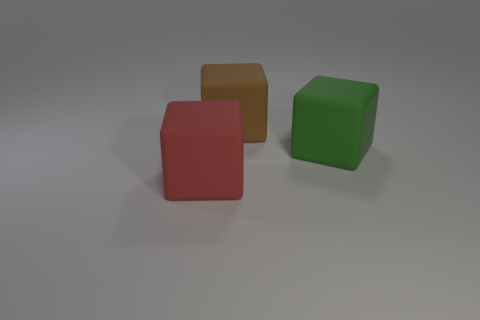Add 3 cubes. How many objects exist? 6 Subtract all large brown rubber blocks. How many blocks are left? 2 Subtract 0 brown balls. How many objects are left? 3 Subtract all cyan cubes. Subtract all yellow balls. How many cubes are left? 3 Subtract all brown spheres. How many gray cubes are left? 0 Subtract all big brown things. Subtract all green cubes. How many objects are left? 1 Add 2 big green rubber things. How many big green rubber things are left? 3 Add 3 small gray shiny cylinders. How many small gray shiny cylinders exist? 3 Subtract all red cubes. How many cubes are left? 2 